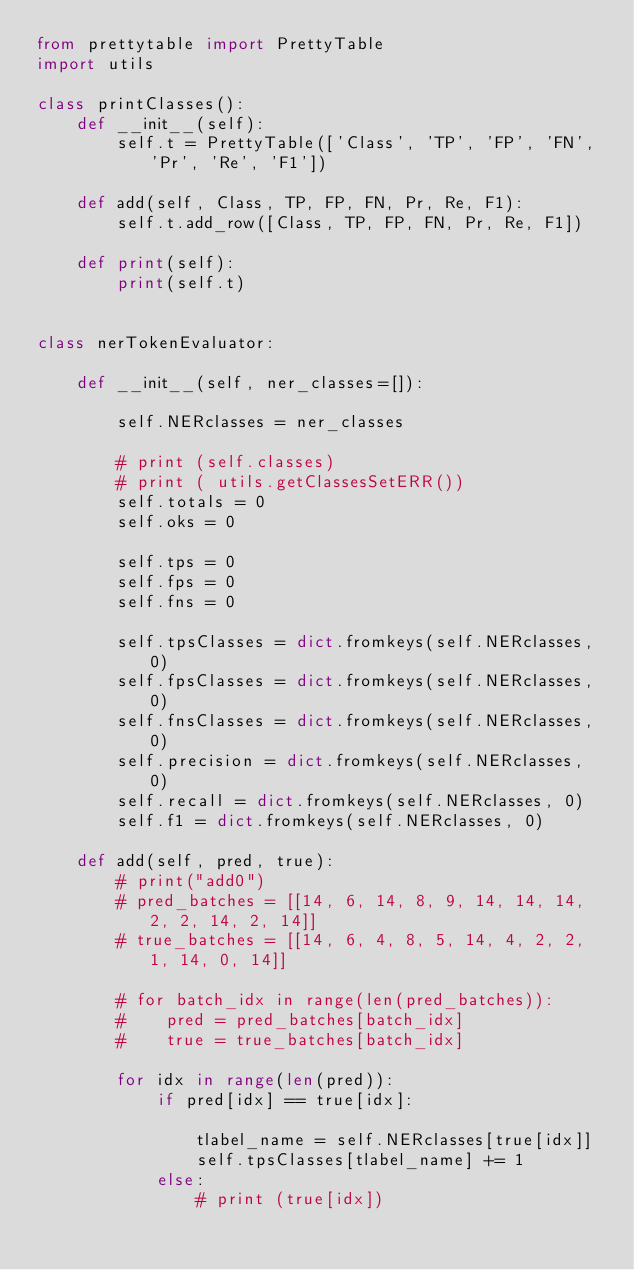Convert code to text. <code><loc_0><loc_0><loc_500><loc_500><_Python_>from prettytable import PrettyTable
import utils

class printClasses():
    def __init__(self):
        self.t = PrettyTable(['Class', 'TP', 'FP', 'FN', 'Pr', 'Re', 'F1'])

    def add(self, Class, TP, FP, FN, Pr, Re, F1):
        self.t.add_row([Class, TP, FP, FN, Pr, Re, F1])

    def print(self):
        print(self.t)


class nerTokenEvaluator:

    def __init__(self, ner_classes=[]):

        self.NERclasses = ner_classes

        # print (self.classes)
        # print ( utils.getClassesSetERR())
        self.totals = 0
        self.oks = 0

        self.tps = 0
        self.fps = 0
        self.fns = 0

        self.tpsClasses = dict.fromkeys(self.NERclasses, 0)
        self.fpsClasses = dict.fromkeys(self.NERclasses, 0)
        self.fnsClasses = dict.fromkeys(self.NERclasses, 0)
        self.precision = dict.fromkeys(self.NERclasses, 0)
        self.recall = dict.fromkeys(self.NERclasses, 0)
        self.f1 = dict.fromkeys(self.NERclasses, 0)

    def add(self, pred, true):
        # print("add0")
        # pred_batches = [[14, 6, 14, 8, 9, 14, 14, 14, 2, 2, 14, 2, 14]]
        # true_batches = [[14, 6, 4, 8, 5, 14, 4, 2, 2, 1, 14, 0, 14]]

        # for batch_idx in range(len(pred_batches)):
        #    pred = pred_batches[batch_idx]
        #    true = true_batches[batch_idx]

        for idx in range(len(pred)):
            if pred[idx] == true[idx]:

                tlabel_name = self.NERclasses[true[idx]]
                self.tpsClasses[tlabel_name] += 1
            else:
                # print (true[idx])</code> 